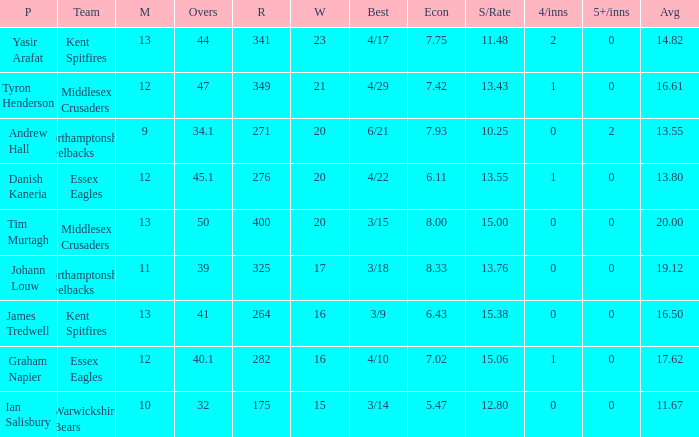Name the most wickets for best is 4/22 20.0. 